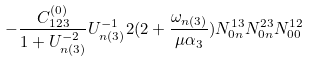Convert formula to latex. <formula><loc_0><loc_0><loc_500><loc_500>- \frac { C ^ { ( 0 ) } _ { 1 2 3 } } { 1 + U ^ { - 2 } _ { n ( 3 ) } } U ^ { - 1 } _ { n ( 3 ) } 2 ( 2 + \frac { \omega _ { n ( 3 ) } } { \mu \alpha _ { 3 } } ) N ^ { 1 3 } _ { 0 n } N ^ { 2 3 } _ { 0 n } N ^ { 1 2 } _ { 0 0 }</formula> 